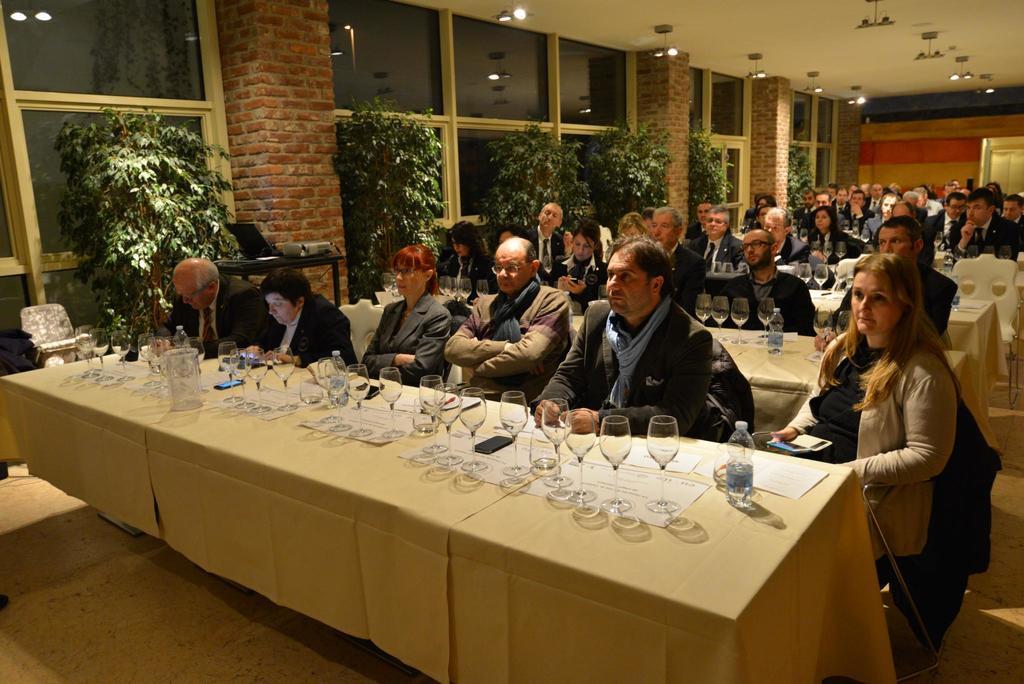In one or two sentences, can you explain what this image depicts? This picture shows a meeting room ,here all the people are seated in the chairs and we see tables in front of them and on the table ,we can see water bottles and glasses on the left side we see plants 